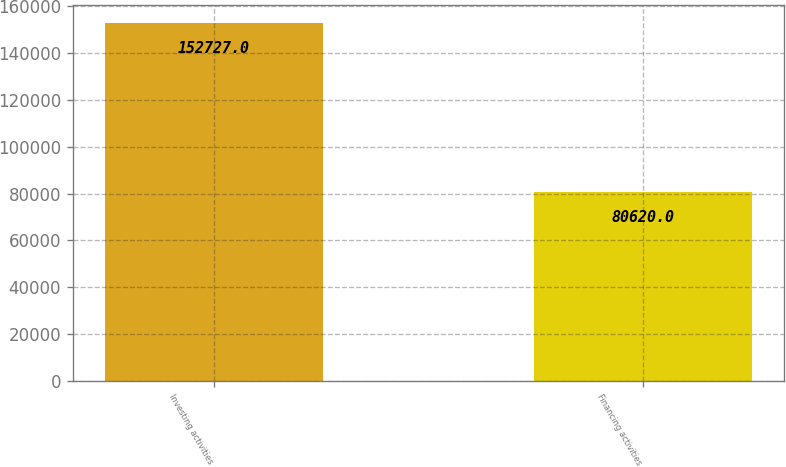<chart> <loc_0><loc_0><loc_500><loc_500><bar_chart><fcel>Investing activities<fcel>Financing activities<nl><fcel>152727<fcel>80620<nl></chart> 